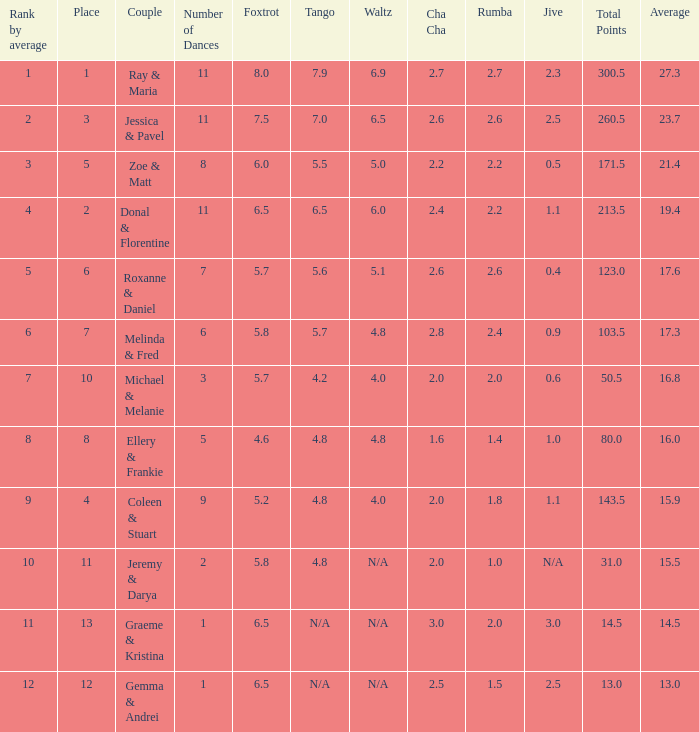What is the couples name where the average is 15.9? Coleen & Stuart. 